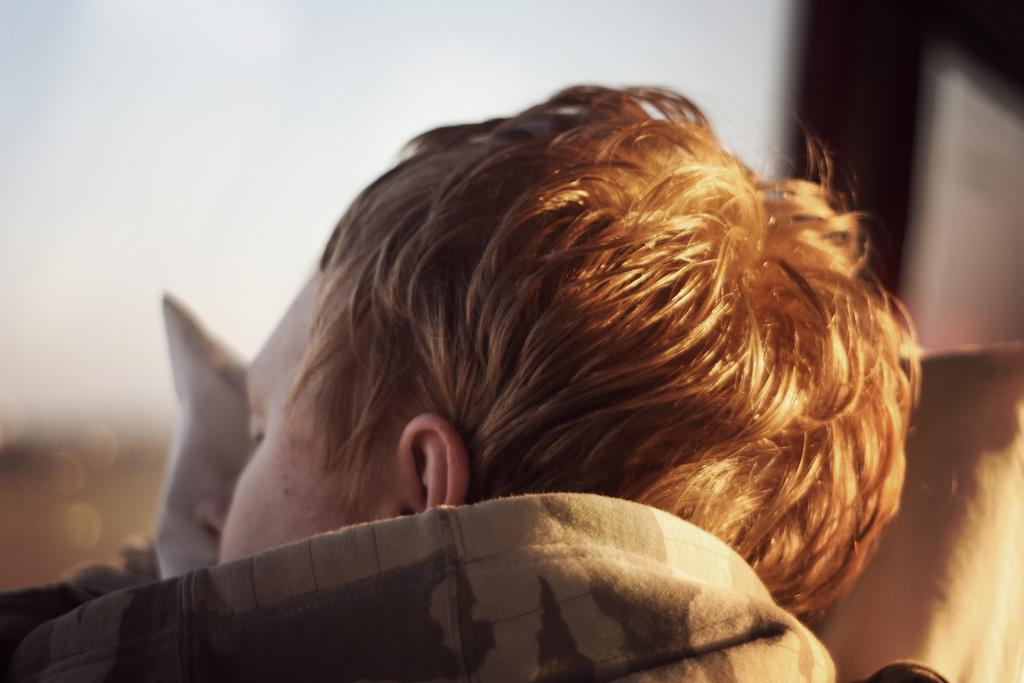What is happening to the person in the image? The person is sleeping in the image. Where is the person resting their head? The person is on a pillow. Can you describe the background of the image? The background of the image is blurry. What is the purpose of the cloth in the image? There is no cloth present in the image. 